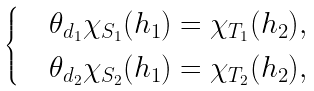<formula> <loc_0><loc_0><loc_500><loc_500>\begin{cases} & \theta _ { d _ { 1 } } \chi _ { S _ { 1 } } ( h _ { 1 } ) = \chi _ { T _ { 1 } } ( h _ { 2 } ) , \\ & \theta _ { d _ { 2 } } \chi _ { S _ { 2 } } ( h _ { 1 } ) = \chi _ { T _ { 2 } } ( h _ { 2 } ) , \end{cases}</formula> 